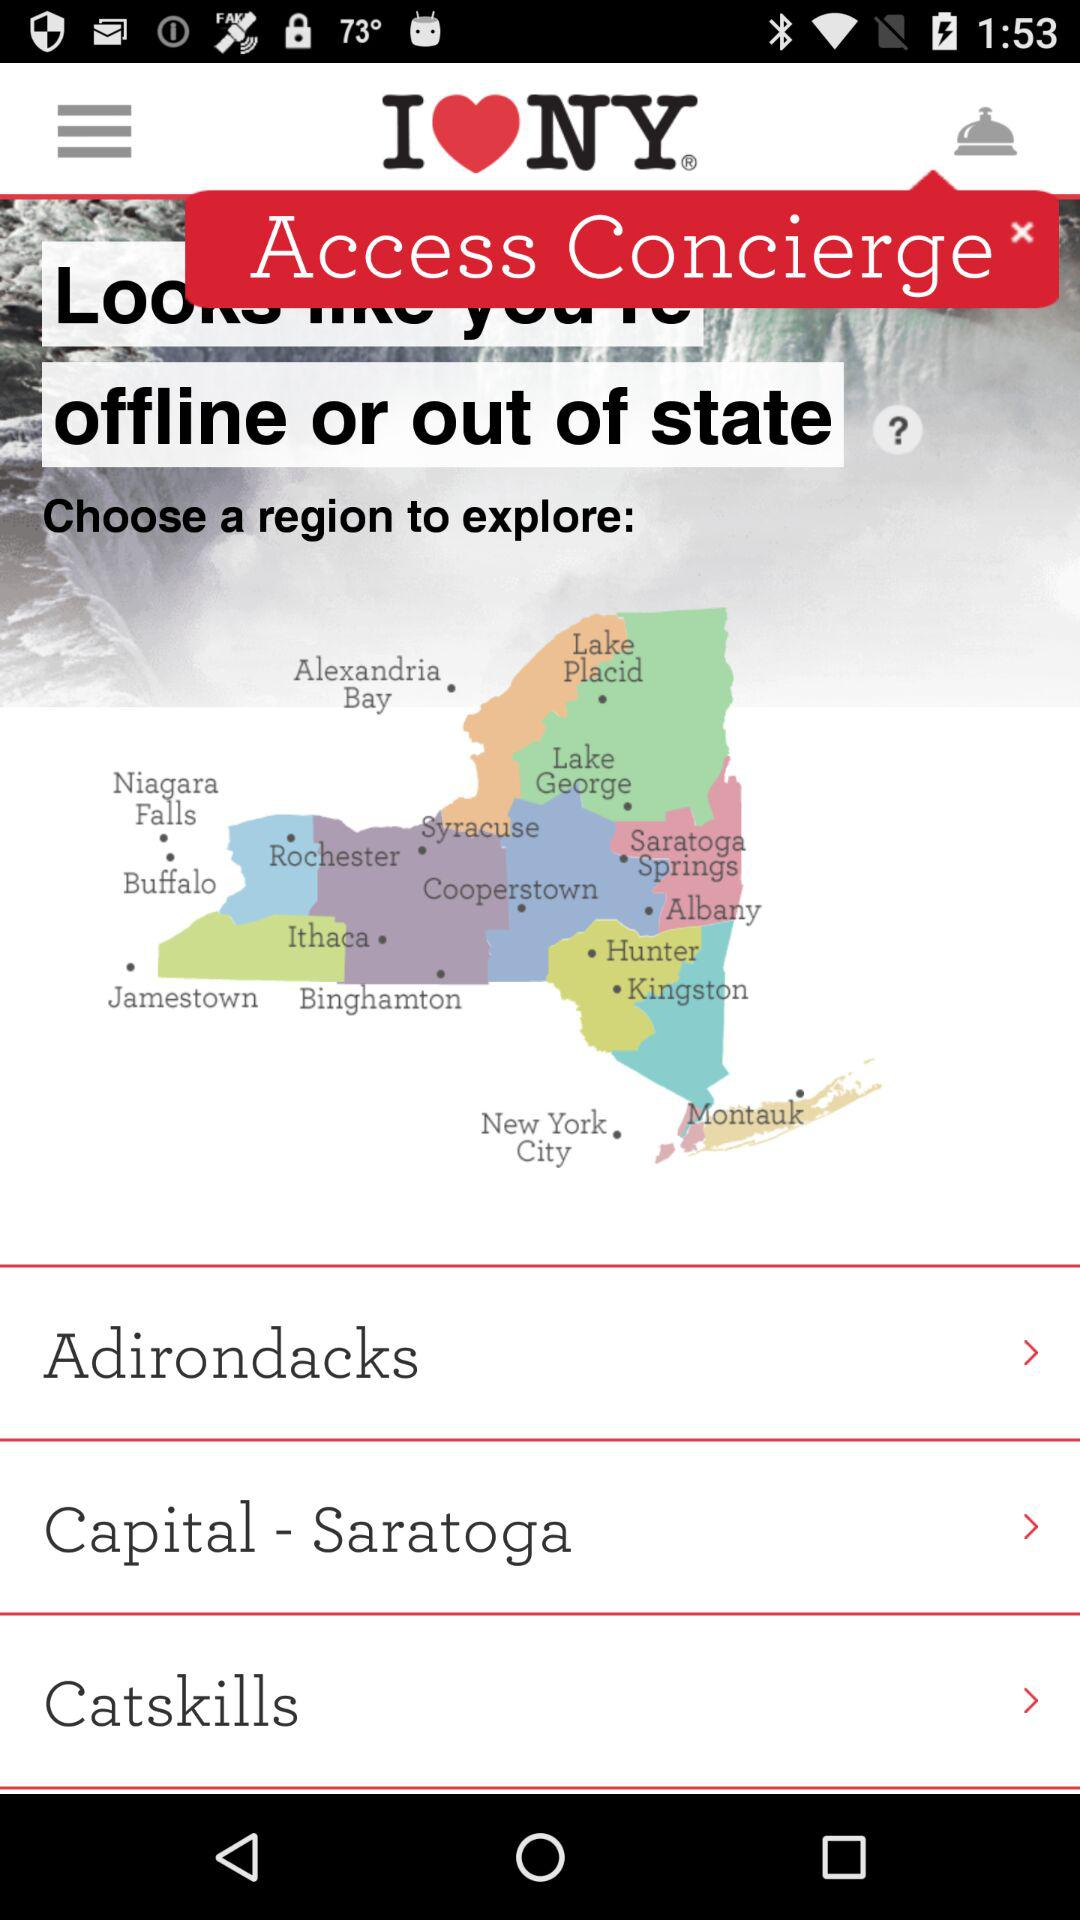What is the application name? The application name is "I❤️NY". 